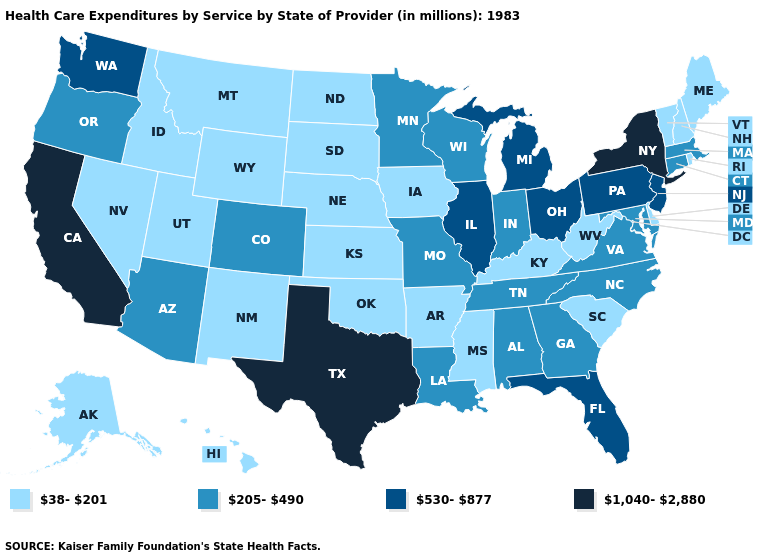What is the lowest value in the USA?
Give a very brief answer. 38-201. What is the value of Virginia?
Concise answer only. 205-490. What is the value of New York?
Be succinct. 1,040-2,880. Name the states that have a value in the range 1,040-2,880?
Give a very brief answer. California, New York, Texas. Among the states that border Kansas , does Oklahoma have the lowest value?
Concise answer only. Yes. Among the states that border Pennsylvania , which have the highest value?
Keep it brief. New York. What is the highest value in the Northeast ?
Write a very short answer. 1,040-2,880. Among the states that border Utah , which have the highest value?
Give a very brief answer. Arizona, Colorado. What is the value of Maryland?
Write a very short answer. 205-490. Does Louisiana have the lowest value in the USA?
Give a very brief answer. No. What is the value of Ohio?
Keep it brief. 530-877. What is the value of North Dakota?
Write a very short answer. 38-201. What is the lowest value in the USA?
Be succinct. 38-201. Among the states that border Missouri , does Iowa have the lowest value?
Be succinct. Yes. 